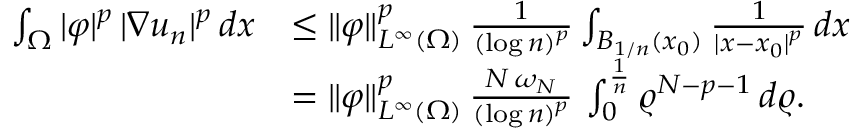<formula> <loc_0><loc_0><loc_500><loc_500>\begin{array} { r l } { \int _ { \Omega } | \varphi | ^ { p } \, | \nabla u _ { n } | ^ { p } \, d x } & { \leq \| \varphi \| _ { L ^ { \infty } ( \Omega ) } ^ { p } \, \frac { 1 } { ( \log n ) ^ { p } } \int _ { B _ { 1 / n } ( x _ { 0 } ) } \frac { 1 } { | x - x _ { 0 } | ^ { p } } \, d x } \\ & { = \| \varphi \| _ { L ^ { \infty } ( \Omega ) } ^ { p } \, \frac { N \, \omega _ { N } } { ( \log n ) ^ { p } } \, \int _ { 0 } ^ { \frac { 1 } { n } } \varrho ^ { N - p - 1 } \, d \varrho . } \end{array}</formula> 